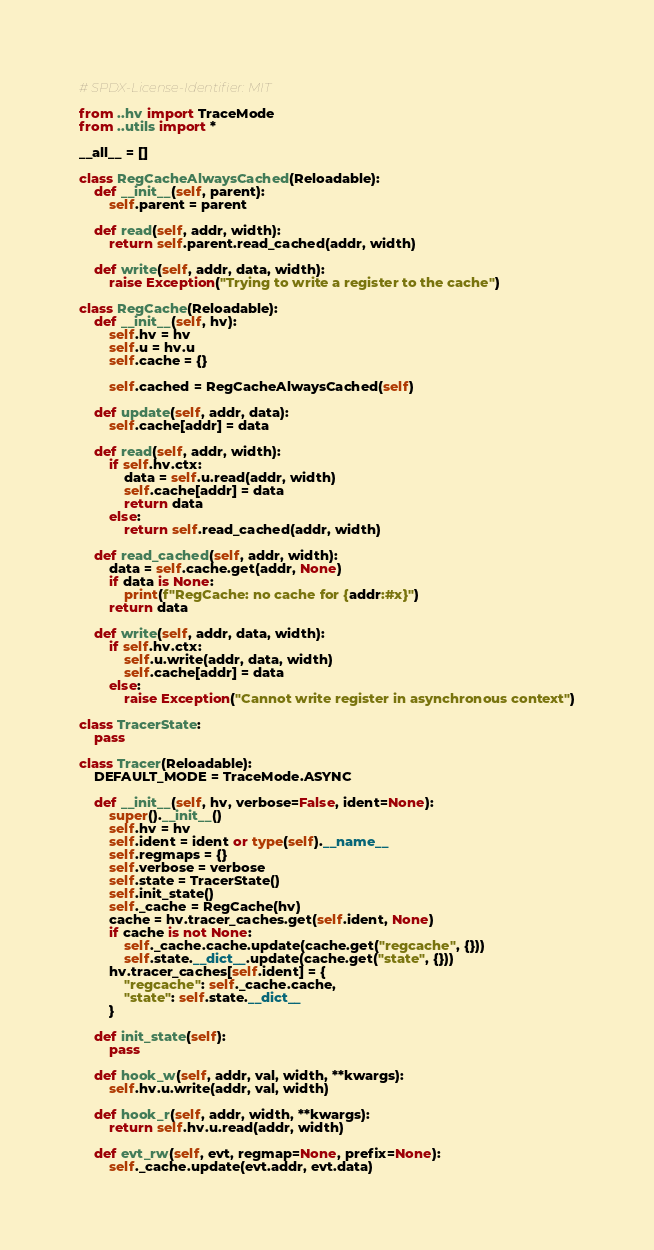<code> <loc_0><loc_0><loc_500><loc_500><_Python_># SPDX-License-Identifier: MIT

from ..hv import TraceMode
from ..utils import *

__all__ = []

class RegCacheAlwaysCached(Reloadable):
    def __init__(self, parent):
        self.parent = parent

    def read(self, addr, width):
        return self.parent.read_cached(addr, width)

    def write(self, addr, data, width):
        raise Exception("Trying to write a register to the cache")

class RegCache(Reloadable):
    def __init__(self, hv):
        self.hv = hv
        self.u = hv.u
        self.cache = {}

        self.cached = RegCacheAlwaysCached(self)

    def update(self, addr, data):
        self.cache[addr] = data

    def read(self, addr, width):
        if self.hv.ctx:
            data = self.u.read(addr, width)
            self.cache[addr] = data
            return data
        else:
            return self.read_cached(addr, width)

    def read_cached(self, addr, width):
        data = self.cache.get(addr, None)
        if data is None:
            print(f"RegCache: no cache for {addr:#x}")
        return data

    def write(self, addr, data, width):
        if self.hv.ctx:
            self.u.write(addr, data, width)
            self.cache[addr] = data
        else:
            raise Exception("Cannot write register in asynchronous context")

class TracerState:
    pass

class Tracer(Reloadable):
    DEFAULT_MODE = TraceMode.ASYNC

    def __init__(self, hv, verbose=False, ident=None):
        super().__init__()
        self.hv = hv
        self.ident = ident or type(self).__name__
        self.regmaps = {}
        self.verbose = verbose
        self.state = TracerState()
        self.init_state()
        self._cache = RegCache(hv)
        cache = hv.tracer_caches.get(self.ident, None)
        if cache is not None:
            self._cache.cache.update(cache.get("regcache", {}))
            self.state.__dict__.update(cache.get("state", {}))
        hv.tracer_caches[self.ident] = {
            "regcache": self._cache.cache,
            "state": self.state.__dict__
        }

    def init_state(self):
        pass

    def hook_w(self, addr, val, width, **kwargs):
        self.hv.u.write(addr, val, width)

    def hook_r(self, addr, width, **kwargs):
        return self.hv.u.read(addr, width)

    def evt_rw(self, evt, regmap=None, prefix=None):
        self._cache.update(evt.addr, evt.data)</code> 